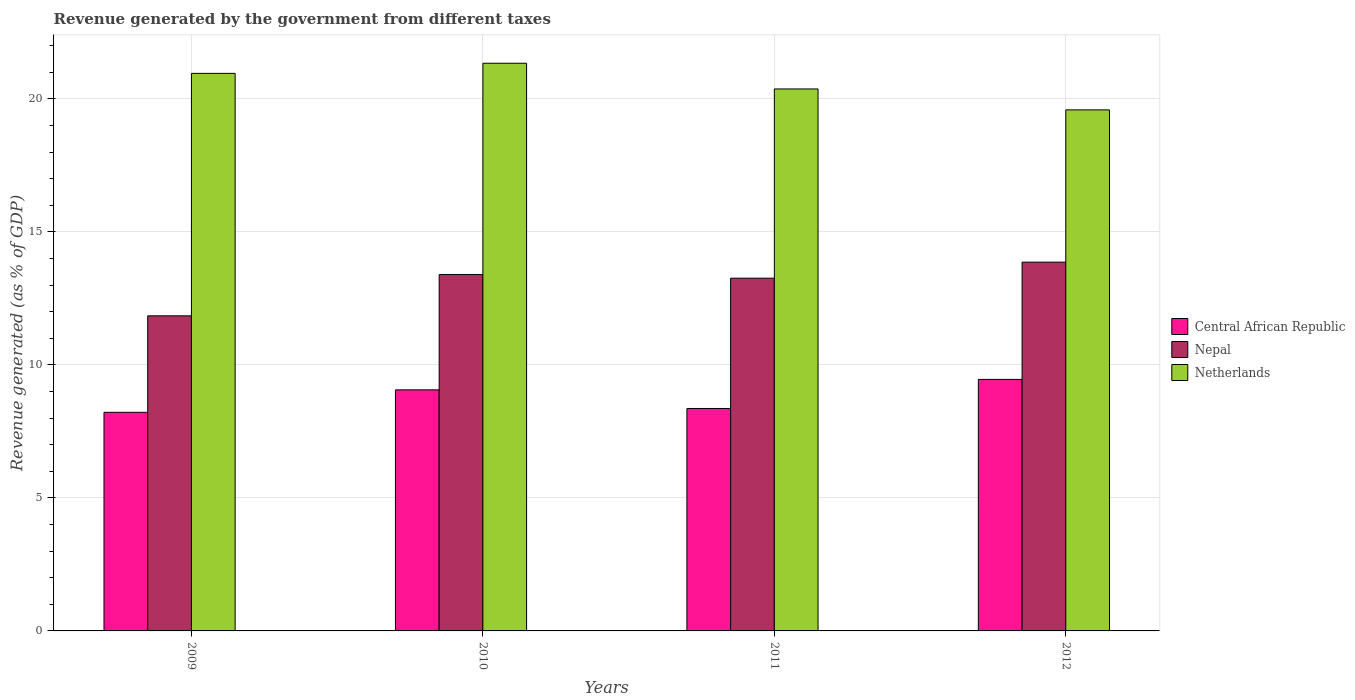How many bars are there on the 2nd tick from the left?
Provide a short and direct response. 3. How many bars are there on the 2nd tick from the right?
Offer a terse response. 3. In how many cases, is the number of bars for a given year not equal to the number of legend labels?
Provide a short and direct response. 0. What is the revenue generated by the government in Netherlands in 2011?
Keep it short and to the point. 20.37. Across all years, what is the maximum revenue generated by the government in Nepal?
Ensure brevity in your answer.  13.86. Across all years, what is the minimum revenue generated by the government in Central African Republic?
Keep it short and to the point. 8.22. In which year was the revenue generated by the government in Netherlands minimum?
Offer a terse response. 2012. What is the total revenue generated by the government in Central African Republic in the graph?
Provide a short and direct response. 35.1. What is the difference between the revenue generated by the government in Netherlands in 2011 and that in 2012?
Offer a very short reply. 0.79. What is the difference between the revenue generated by the government in Central African Republic in 2009 and the revenue generated by the government in Nepal in 2012?
Offer a terse response. -5.64. What is the average revenue generated by the government in Netherlands per year?
Provide a short and direct response. 20.56. In the year 2011, what is the difference between the revenue generated by the government in Nepal and revenue generated by the government in Central African Republic?
Your answer should be compact. 4.9. What is the ratio of the revenue generated by the government in Central African Republic in 2011 to that in 2012?
Provide a short and direct response. 0.88. What is the difference between the highest and the second highest revenue generated by the government in Netherlands?
Provide a short and direct response. 0.38. What is the difference between the highest and the lowest revenue generated by the government in Nepal?
Make the answer very short. 2.02. In how many years, is the revenue generated by the government in Nepal greater than the average revenue generated by the government in Nepal taken over all years?
Offer a very short reply. 3. Is the sum of the revenue generated by the government in Nepal in 2009 and 2010 greater than the maximum revenue generated by the government in Netherlands across all years?
Your answer should be very brief. Yes. What does the 3rd bar from the right in 2009 represents?
Your response must be concise. Central African Republic. How many bars are there?
Ensure brevity in your answer.  12. Are the values on the major ticks of Y-axis written in scientific E-notation?
Offer a very short reply. No. Does the graph contain grids?
Ensure brevity in your answer.  Yes. What is the title of the graph?
Your answer should be compact. Revenue generated by the government from different taxes. Does "Central African Republic" appear as one of the legend labels in the graph?
Your response must be concise. Yes. What is the label or title of the X-axis?
Your response must be concise. Years. What is the label or title of the Y-axis?
Your response must be concise. Revenue generated (as % of GDP). What is the Revenue generated (as % of GDP) in Central African Republic in 2009?
Provide a succinct answer. 8.22. What is the Revenue generated (as % of GDP) of Nepal in 2009?
Keep it short and to the point. 11.84. What is the Revenue generated (as % of GDP) of Netherlands in 2009?
Your answer should be very brief. 20.96. What is the Revenue generated (as % of GDP) of Central African Republic in 2010?
Keep it short and to the point. 9.06. What is the Revenue generated (as % of GDP) in Nepal in 2010?
Provide a short and direct response. 13.4. What is the Revenue generated (as % of GDP) in Netherlands in 2010?
Give a very brief answer. 21.34. What is the Revenue generated (as % of GDP) in Central African Republic in 2011?
Ensure brevity in your answer.  8.36. What is the Revenue generated (as % of GDP) of Nepal in 2011?
Offer a very short reply. 13.26. What is the Revenue generated (as % of GDP) of Netherlands in 2011?
Your answer should be compact. 20.37. What is the Revenue generated (as % of GDP) in Central African Republic in 2012?
Your answer should be compact. 9.46. What is the Revenue generated (as % of GDP) in Nepal in 2012?
Keep it short and to the point. 13.86. What is the Revenue generated (as % of GDP) in Netherlands in 2012?
Offer a terse response. 19.59. Across all years, what is the maximum Revenue generated (as % of GDP) in Central African Republic?
Offer a very short reply. 9.46. Across all years, what is the maximum Revenue generated (as % of GDP) in Nepal?
Your response must be concise. 13.86. Across all years, what is the maximum Revenue generated (as % of GDP) of Netherlands?
Offer a terse response. 21.34. Across all years, what is the minimum Revenue generated (as % of GDP) of Central African Republic?
Provide a short and direct response. 8.22. Across all years, what is the minimum Revenue generated (as % of GDP) in Nepal?
Offer a very short reply. 11.84. Across all years, what is the minimum Revenue generated (as % of GDP) of Netherlands?
Offer a very short reply. 19.59. What is the total Revenue generated (as % of GDP) of Central African Republic in the graph?
Make the answer very short. 35.1. What is the total Revenue generated (as % of GDP) in Nepal in the graph?
Offer a terse response. 52.36. What is the total Revenue generated (as % of GDP) of Netherlands in the graph?
Give a very brief answer. 82.26. What is the difference between the Revenue generated (as % of GDP) in Central African Republic in 2009 and that in 2010?
Provide a succinct answer. -0.84. What is the difference between the Revenue generated (as % of GDP) of Nepal in 2009 and that in 2010?
Make the answer very short. -1.55. What is the difference between the Revenue generated (as % of GDP) of Netherlands in 2009 and that in 2010?
Your answer should be very brief. -0.38. What is the difference between the Revenue generated (as % of GDP) in Central African Republic in 2009 and that in 2011?
Your answer should be compact. -0.14. What is the difference between the Revenue generated (as % of GDP) of Nepal in 2009 and that in 2011?
Your answer should be very brief. -1.42. What is the difference between the Revenue generated (as % of GDP) in Netherlands in 2009 and that in 2011?
Give a very brief answer. 0.59. What is the difference between the Revenue generated (as % of GDP) of Central African Republic in 2009 and that in 2012?
Your response must be concise. -1.24. What is the difference between the Revenue generated (as % of GDP) in Nepal in 2009 and that in 2012?
Your answer should be compact. -2.02. What is the difference between the Revenue generated (as % of GDP) of Netherlands in 2009 and that in 2012?
Offer a very short reply. 1.37. What is the difference between the Revenue generated (as % of GDP) of Central African Republic in 2010 and that in 2011?
Make the answer very short. 0.7. What is the difference between the Revenue generated (as % of GDP) in Nepal in 2010 and that in 2011?
Offer a terse response. 0.14. What is the difference between the Revenue generated (as % of GDP) in Netherlands in 2010 and that in 2011?
Ensure brevity in your answer.  0.97. What is the difference between the Revenue generated (as % of GDP) in Central African Republic in 2010 and that in 2012?
Your answer should be very brief. -0.39. What is the difference between the Revenue generated (as % of GDP) in Nepal in 2010 and that in 2012?
Ensure brevity in your answer.  -0.47. What is the difference between the Revenue generated (as % of GDP) of Netherlands in 2010 and that in 2012?
Keep it short and to the point. 1.75. What is the difference between the Revenue generated (as % of GDP) in Central African Republic in 2011 and that in 2012?
Your answer should be compact. -1.09. What is the difference between the Revenue generated (as % of GDP) of Nepal in 2011 and that in 2012?
Your answer should be compact. -0.6. What is the difference between the Revenue generated (as % of GDP) in Netherlands in 2011 and that in 2012?
Provide a short and direct response. 0.79. What is the difference between the Revenue generated (as % of GDP) in Central African Republic in 2009 and the Revenue generated (as % of GDP) in Nepal in 2010?
Your response must be concise. -5.18. What is the difference between the Revenue generated (as % of GDP) in Central African Republic in 2009 and the Revenue generated (as % of GDP) in Netherlands in 2010?
Give a very brief answer. -13.12. What is the difference between the Revenue generated (as % of GDP) of Nepal in 2009 and the Revenue generated (as % of GDP) of Netherlands in 2010?
Keep it short and to the point. -9.49. What is the difference between the Revenue generated (as % of GDP) of Central African Republic in 2009 and the Revenue generated (as % of GDP) of Nepal in 2011?
Your answer should be compact. -5.04. What is the difference between the Revenue generated (as % of GDP) of Central African Republic in 2009 and the Revenue generated (as % of GDP) of Netherlands in 2011?
Give a very brief answer. -12.16. What is the difference between the Revenue generated (as % of GDP) of Nepal in 2009 and the Revenue generated (as % of GDP) of Netherlands in 2011?
Provide a succinct answer. -8.53. What is the difference between the Revenue generated (as % of GDP) in Central African Republic in 2009 and the Revenue generated (as % of GDP) in Nepal in 2012?
Provide a short and direct response. -5.64. What is the difference between the Revenue generated (as % of GDP) of Central African Republic in 2009 and the Revenue generated (as % of GDP) of Netherlands in 2012?
Keep it short and to the point. -11.37. What is the difference between the Revenue generated (as % of GDP) in Nepal in 2009 and the Revenue generated (as % of GDP) in Netherlands in 2012?
Your response must be concise. -7.74. What is the difference between the Revenue generated (as % of GDP) of Central African Republic in 2010 and the Revenue generated (as % of GDP) of Nepal in 2011?
Provide a succinct answer. -4.2. What is the difference between the Revenue generated (as % of GDP) in Central African Republic in 2010 and the Revenue generated (as % of GDP) in Netherlands in 2011?
Your response must be concise. -11.31. What is the difference between the Revenue generated (as % of GDP) of Nepal in 2010 and the Revenue generated (as % of GDP) of Netherlands in 2011?
Give a very brief answer. -6.98. What is the difference between the Revenue generated (as % of GDP) in Central African Republic in 2010 and the Revenue generated (as % of GDP) in Nepal in 2012?
Provide a succinct answer. -4.8. What is the difference between the Revenue generated (as % of GDP) in Central African Republic in 2010 and the Revenue generated (as % of GDP) in Netherlands in 2012?
Your answer should be compact. -10.52. What is the difference between the Revenue generated (as % of GDP) in Nepal in 2010 and the Revenue generated (as % of GDP) in Netherlands in 2012?
Offer a very short reply. -6.19. What is the difference between the Revenue generated (as % of GDP) of Central African Republic in 2011 and the Revenue generated (as % of GDP) of Nepal in 2012?
Offer a very short reply. -5.5. What is the difference between the Revenue generated (as % of GDP) of Central African Republic in 2011 and the Revenue generated (as % of GDP) of Netherlands in 2012?
Keep it short and to the point. -11.22. What is the difference between the Revenue generated (as % of GDP) in Nepal in 2011 and the Revenue generated (as % of GDP) in Netherlands in 2012?
Offer a very short reply. -6.33. What is the average Revenue generated (as % of GDP) of Central African Republic per year?
Provide a short and direct response. 8.77. What is the average Revenue generated (as % of GDP) in Nepal per year?
Your answer should be compact. 13.09. What is the average Revenue generated (as % of GDP) in Netherlands per year?
Your answer should be very brief. 20.56. In the year 2009, what is the difference between the Revenue generated (as % of GDP) in Central African Republic and Revenue generated (as % of GDP) in Nepal?
Make the answer very short. -3.63. In the year 2009, what is the difference between the Revenue generated (as % of GDP) in Central African Republic and Revenue generated (as % of GDP) in Netherlands?
Keep it short and to the point. -12.74. In the year 2009, what is the difference between the Revenue generated (as % of GDP) of Nepal and Revenue generated (as % of GDP) of Netherlands?
Make the answer very short. -9.11. In the year 2010, what is the difference between the Revenue generated (as % of GDP) of Central African Republic and Revenue generated (as % of GDP) of Nepal?
Ensure brevity in your answer.  -4.33. In the year 2010, what is the difference between the Revenue generated (as % of GDP) in Central African Republic and Revenue generated (as % of GDP) in Netherlands?
Offer a terse response. -12.28. In the year 2010, what is the difference between the Revenue generated (as % of GDP) of Nepal and Revenue generated (as % of GDP) of Netherlands?
Ensure brevity in your answer.  -7.94. In the year 2011, what is the difference between the Revenue generated (as % of GDP) of Central African Republic and Revenue generated (as % of GDP) of Nepal?
Your answer should be compact. -4.9. In the year 2011, what is the difference between the Revenue generated (as % of GDP) in Central African Republic and Revenue generated (as % of GDP) in Netherlands?
Your response must be concise. -12.01. In the year 2011, what is the difference between the Revenue generated (as % of GDP) of Nepal and Revenue generated (as % of GDP) of Netherlands?
Your answer should be very brief. -7.11. In the year 2012, what is the difference between the Revenue generated (as % of GDP) of Central African Republic and Revenue generated (as % of GDP) of Nepal?
Keep it short and to the point. -4.41. In the year 2012, what is the difference between the Revenue generated (as % of GDP) in Central African Republic and Revenue generated (as % of GDP) in Netherlands?
Offer a very short reply. -10.13. In the year 2012, what is the difference between the Revenue generated (as % of GDP) of Nepal and Revenue generated (as % of GDP) of Netherlands?
Your answer should be compact. -5.72. What is the ratio of the Revenue generated (as % of GDP) of Central African Republic in 2009 to that in 2010?
Give a very brief answer. 0.91. What is the ratio of the Revenue generated (as % of GDP) in Nepal in 2009 to that in 2010?
Provide a short and direct response. 0.88. What is the ratio of the Revenue generated (as % of GDP) of Netherlands in 2009 to that in 2010?
Offer a terse response. 0.98. What is the ratio of the Revenue generated (as % of GDP) of Central African Republic in 2009 to that in 2011?
Your answer should be compact. 0.98. What is the ratio of the Revenue generated (as % of GDP) of Nepal in 2009 to that in 2011?
Your answer should be very brief. 0.89. What is the ratio of the Revenue generated (as % of GDP) of Netherlands in 2009 to that in 2011?
Make the answer very short. 1.03. What is the ratio of the Revenue generated (as % of GDP) in Central African Republic in 2009 to that in 2012?
Your response must be concise. 0.87. What is the ratio of the Revenue generated (as % of GDP) of Nepal in 2009 to that in 2012?
Provide a short and direct response. 0.85. What is the ratio of the Revenue generated (as % of GDP) of Netherlands in 2009 to that in 2012?
Make the answer very short. 1.07. What is the ratio of the Revenue generated (as % of GDP) of Central African Republic in 2010 to that in 2011?
Ensure brevity in your answer.  1.08. What is the ratio of the Revenue generated (as % of GDP) in Nepal in 2010 to that in 2011?
Your response must be concise. 1.01. What is the ratio of the Revenue generated (as % of GDP) of Netherlands in 2010 to that in 2011?
Provide a short and direct response. 1.05. What is the ratio of the Revenue generated (as % of GDP) in Central African Republic in 2010 to that in 2012?
Make the answer very short. 0.96. What is the ratio of the Revenue generated (as % of GDP) of Nepal in 2010 to that in 2012?
Give a very brief answer. 0.97. What is the ratio of the Revenue generated (as % of GDP) in Netherlands in 2010 to that in 2012?
Provide a succinct answer. 1.09. What is the ratio of the Revenue generated (as % of GDP) in Central African Republic in 2011 to that in 2012?
Offer a very short reply. 0.88. What is the ratio of the Revenue generated (as % of GDP) in Nepal in 2011 to that in 2012?
Offer a very short reply. 0.96. What is the ratio of the Revenue generated (as % of GDP) of Netherlands in 2011 to that in 2012?
Offer a very short reply. 1.04. What is the difference between the highest and the second highest Revenue generated (as % of GDP) in Central African Republic?
Provide a succinct answer. 0.39. What is the difference between the highest and the second highest Revenue generated (as % of GDP) of Nepal?
Give a very brief answer. 0.47. What is the difference between the highest and the second highest Revenue generated (as % of GDP) in Netherlands?
Offer a very short reply. 0.38. What is the difference between the highest and the lowest Revenue generated (as % of GDP) in Central African Republic?
Provide a succinct answer. 1.24. What is the difference between the highest and the lowest Revenue generated (as % of GDP) of Nepal?
Offer a terse response. 2.02. What is the difference between the highest and the lowest Revenue generated (as % of GDP) of Netherlands?
Make the answer very short. 1.75. 